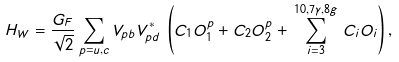Convert formula to latex. <formula><loc_0><loc_0><loc_500><loc_500>H _ { W } = \frac { G _ { F } } { \sqrt { 2 } } \sum _ { p = u , c } V _ { p b } V ^ { * } _ { p d } \, \left ( C _ { 1 } O _ { 1 } ^ { p } + C _ { 2 } O _ { 2 } ^ { p } + \, \sum _ { i = 3 } ^ { 1 0 , 7 \gamma , 8 g } \, C _ { i } O _ { i } \right ) ,</formula> 